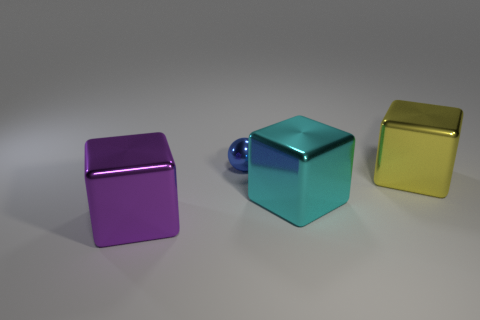Is there anything else that has the same shape as the large cyan metallic thing?
Your answer should be compact. Yes. Are there more small cyan objects than cubes?
Provide a short and direct response. No. How many other things are made of the same material as the blue object?
Offer a very short reply. 3. What shape is the blue shiny object on the left side of the cyan shiny cube in front of the shiny object behind the big yellow object?
Provide a succinct answer. Sphere. Is the number of objects left of the big yellow metal cube less than the number of spheres that are left of the cyan cube?
Keep it short and to the point. No. Is there a big metallic thing of the same color as the small thing?
Your response must be concise. No. Do the yellow thing and the thing behind the yellow shiny object have the same material?
Provide a short and direct response. Yes. There is a blue thing that is on the left side of the cyan metallic object; is there a cyan cube that is to the left of it?
Keep it short and to the point. No. The metallic cube that is to the left of the large yellow block and behind the purple thing is what color?
Make the answer very short. Cyan. The purple cube has what size?
Provide a succinct answer. Large. 